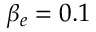<formula> <loc_0><loc_0><loc_500><loc_500>\beta _ { e } = 0 . 1</formula> 